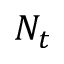<formula> <loc_0><loc_0><loc_500><loc_500>N _ { t }</formula> 